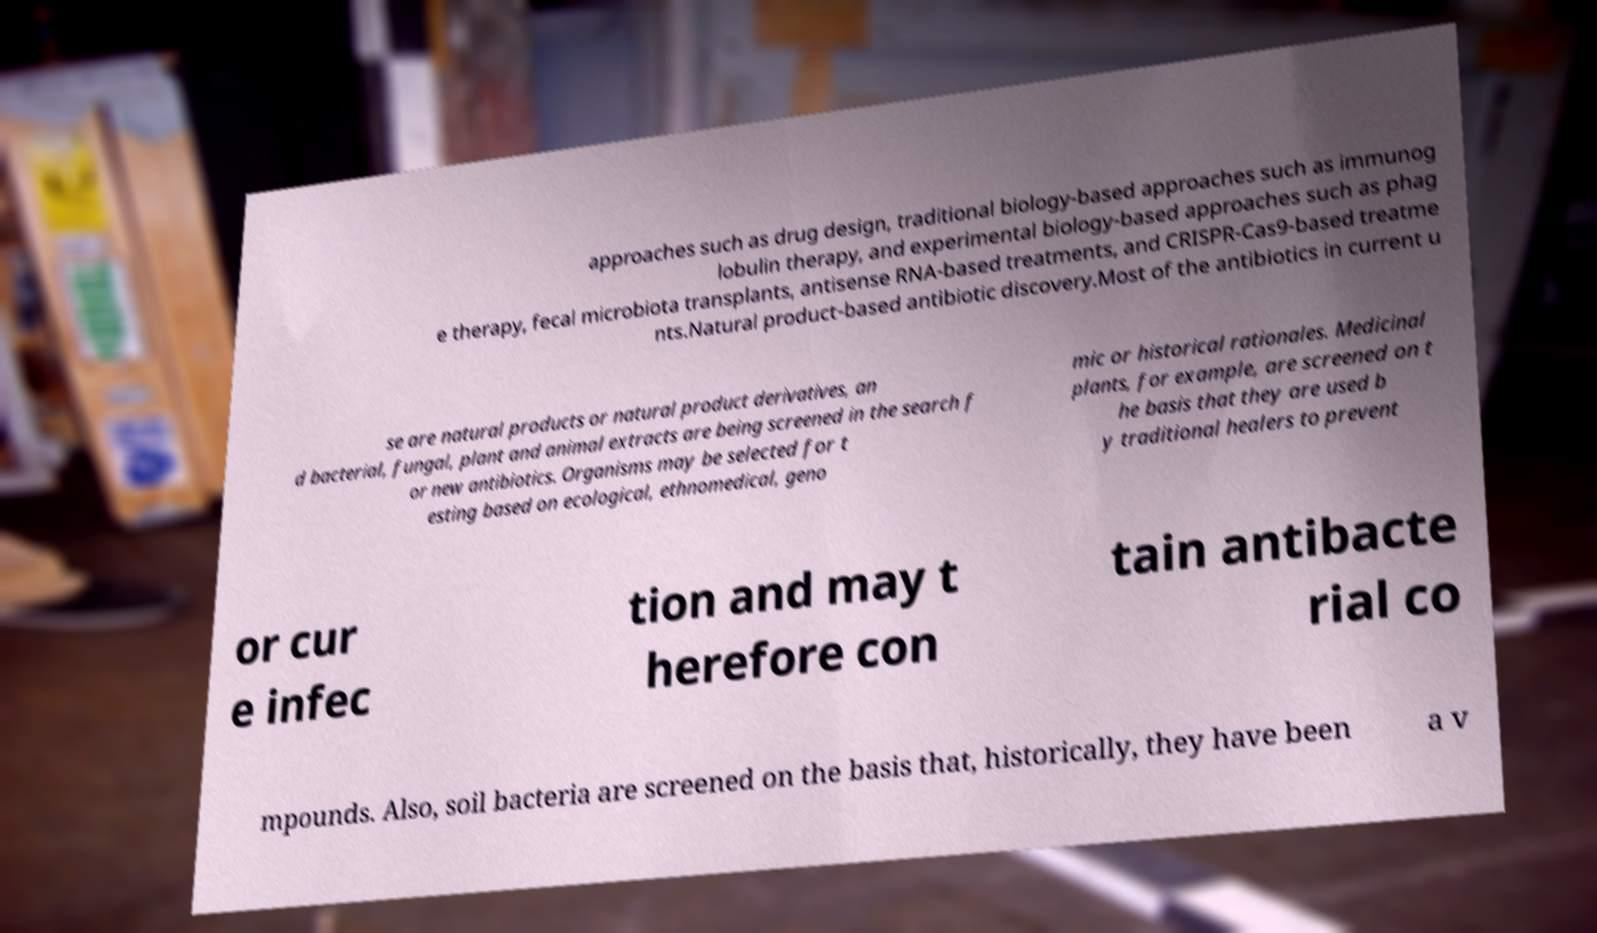Please read and relay the text visible in this image. What does it say? approaches such as drug design, traditional biology-based approaches such as immunog lobulin therapy, and experimental biology-based approaches such as phag e therapy, fecal microbiota transplants, antisense RNA-based treatments, and CRISPR-Cas9-based treatme nts.Natural product-based antibiotic discovery.Most of the antibiotics in current u se are natural products or natural product derivatives, an d bacterial, fungal, plant and animal extracts are being screened in the search f or new antibiotics. Organisms may be selected for t esting based on ecological, ethnomedical, geno mic or historical rationales. Medicinal plants, for example, are screened on t he basis that they are used b y traditional healers to prevent or cur e infec tion and may t herefore con tain antibacte rial co mpounds. Also, soil bacteria are screened on the basis that, historically, they have been a v 